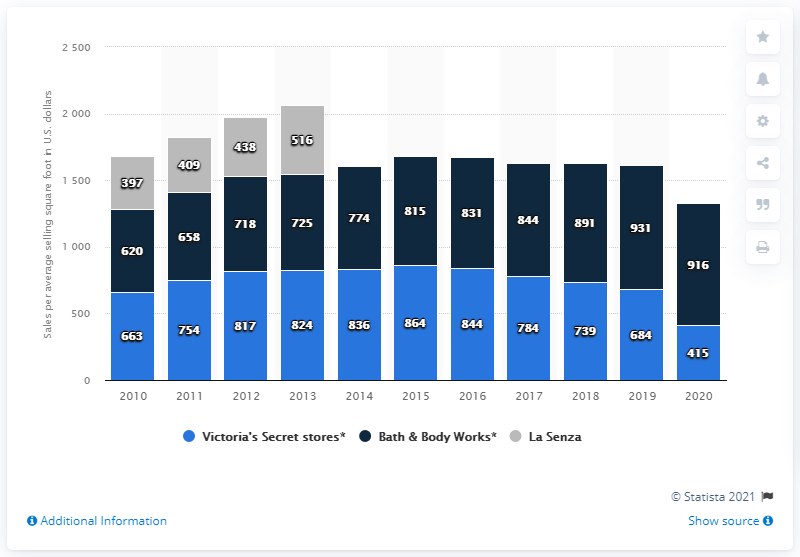Mention a couple of crucial points in this snapshot. In 2020, the average sales per square foot of Victoria's Secret stores was 415, indicating strong sales performance of the company's retail operations. 